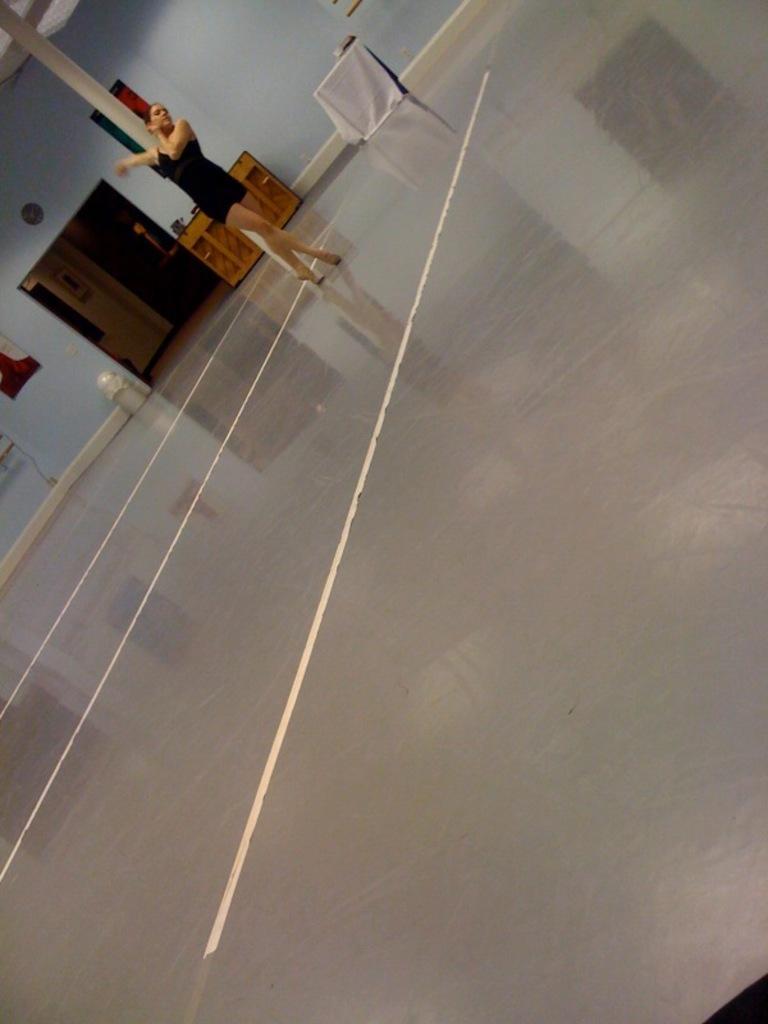How would you summarize this image in a sentence or two? In this image I can see a person on the floor. I can see some objects on the table. In the background, I can see a photo frame on the wall. 